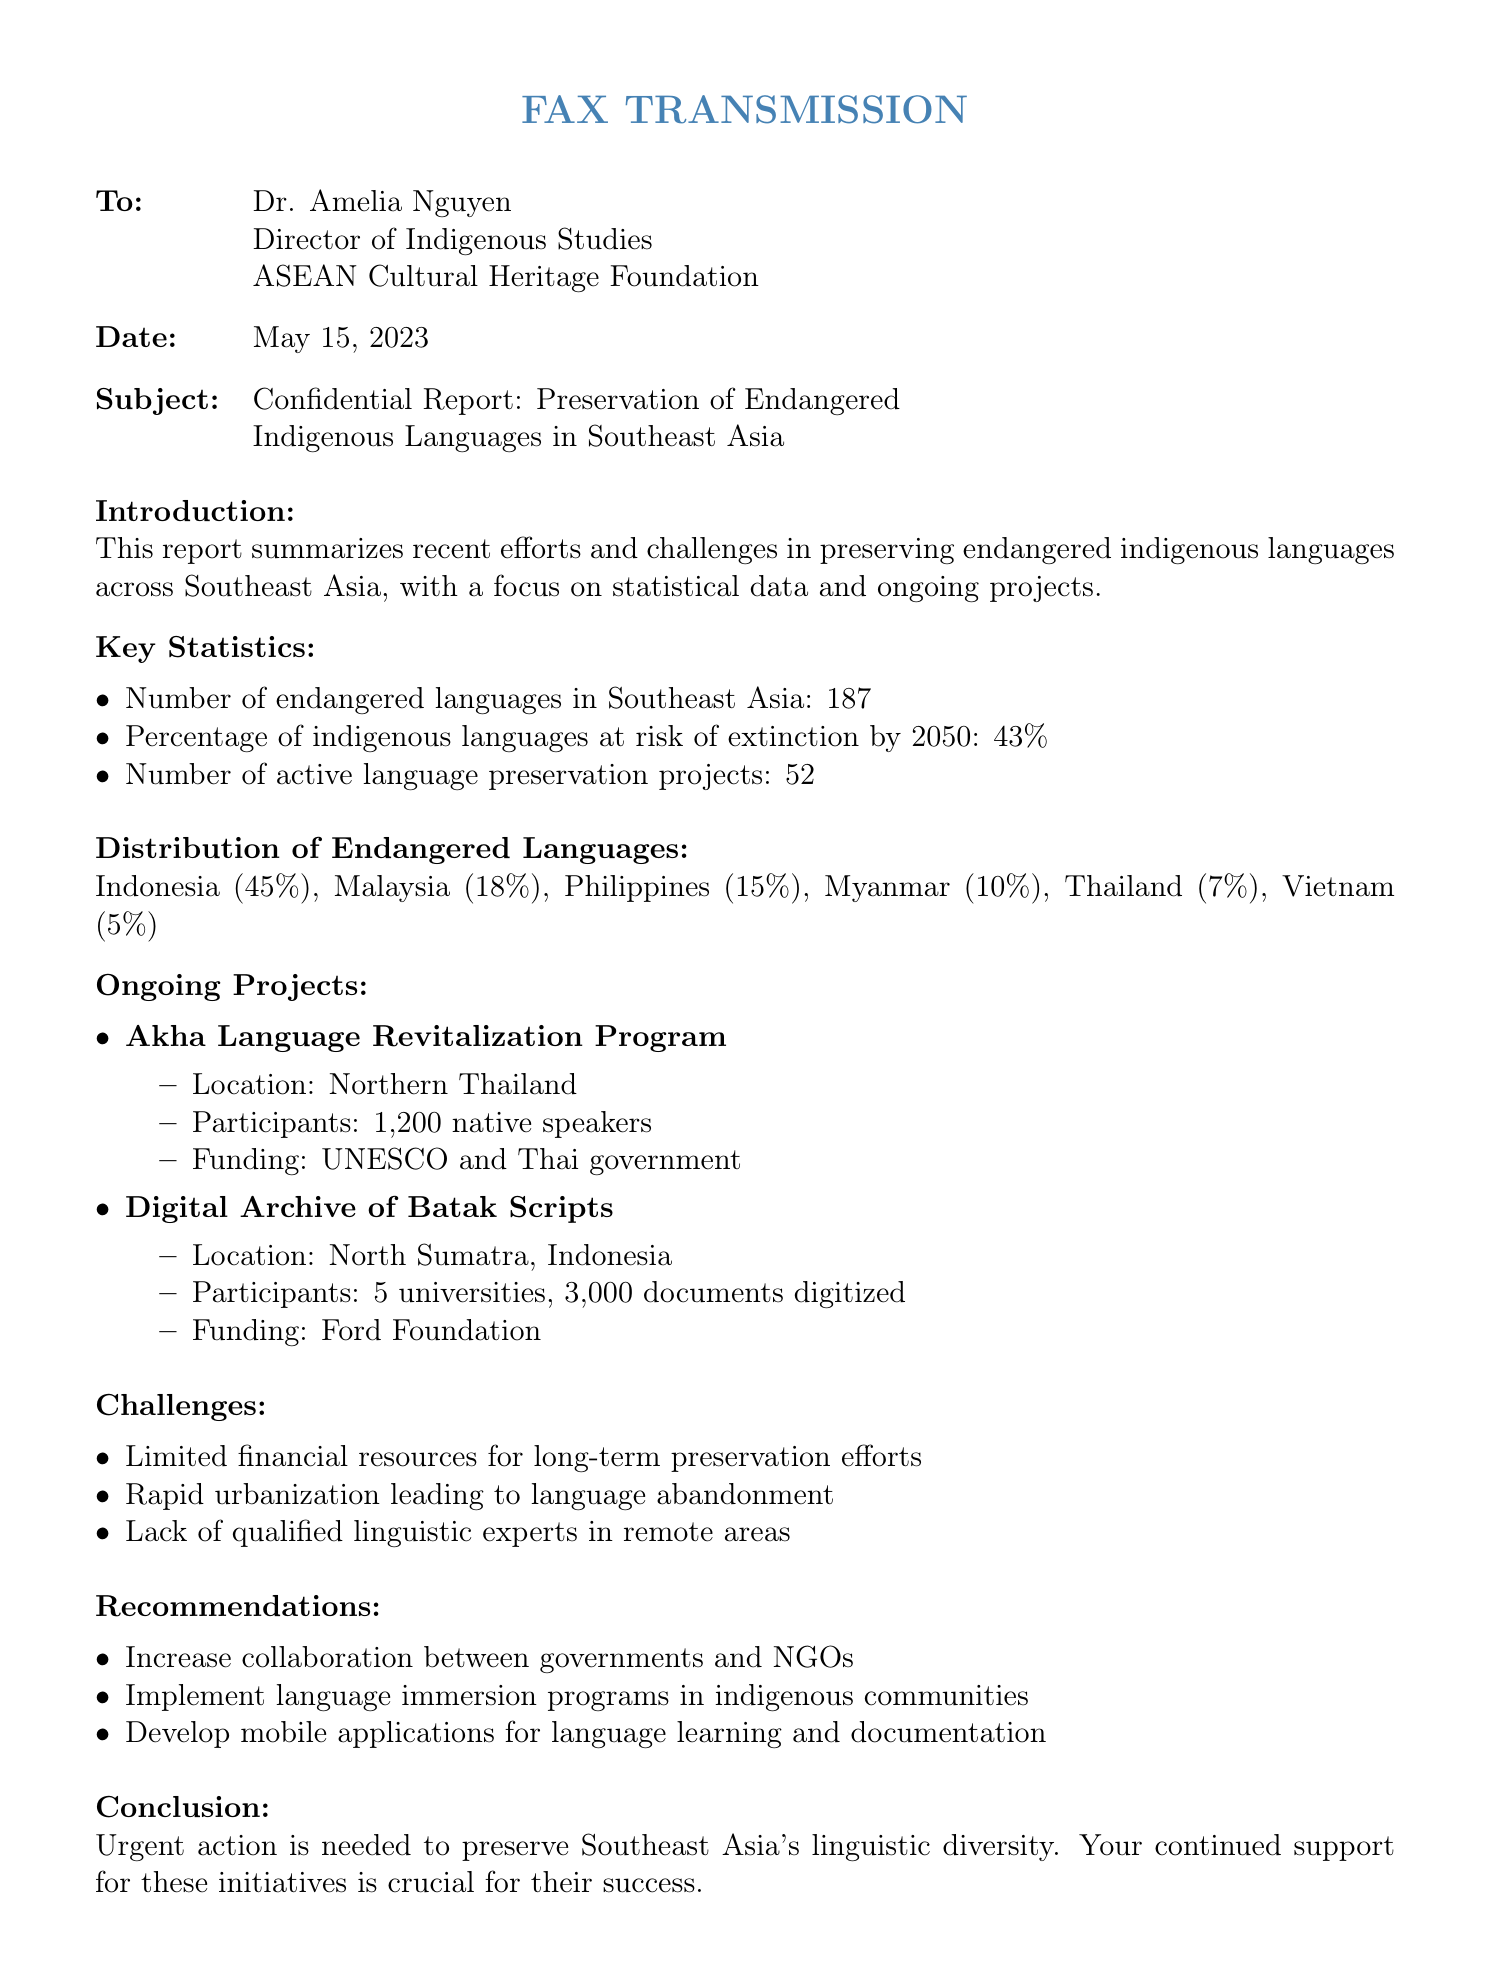What is the total number of endangered languages in Southeast Asia? The total number of endangered languages in Southeast Asia is explicitly stated in the report.
Answer: 187 What percentage of indigenous languages is at risk of extinction by 2050? The report specifies that 43% of indigenous languages are at risk of extinction by 2050.
Answer: 43% How many active language preservation projects are mentioned? The report outlines that there are 52 active language preservation projects in total.
Answer: 52 Which country has the highest percentage of endangered languages? The document provides the percentages of endangered languages by country, indicating Indonesia has the highest at 45%.
Answer: Indonesia What is the funding source for the Digital Archive of Batak Scripts? The funding source for the project is provided in the ongoing projects section of the report.
Answer: Ford Foundation What is one challenge mentioned in the document for language preservation? The document lists specific challenges faced in language preservation, highlighting limited financial resources as a significant issue.
Answer: Limited financial resources What recommendation is given regarding collaboration? The recommendations section suggests that collaboration between specific entities should be increased, as noted in the report.
Answer: Increase collaboration between governments and NGOs What location is the Akha Language Revitalization Program based in? The location for the Akha Language Revitalization Program is clearly identified in the document.
Answer: Northern Thailand What is the total number of documents digitized in the Digital Archive of Batak Scripts? The report specifies the number of documents digitized as part of the project.
Answer: 3,000 documents 